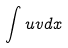<formula> <loc_0><loc_0><loc_500><loc_500>\int u v d x</formula> 